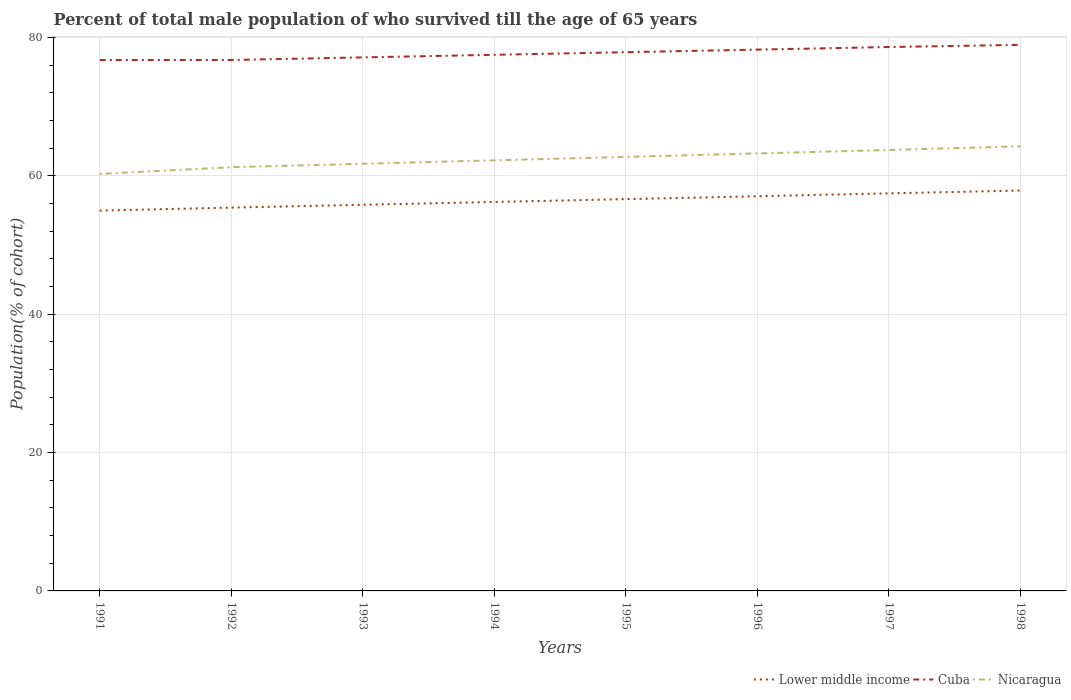Does the line corresponding to Nicaragua intersect with the line corresponding to Lower middle income?
Offer a terse response. No. Is the number of lines equal to the number of legend labels?
Your response must be concise. Yes. Across all years, what is the maximum percentage of total male population who survived till the age of 65 years in Nicaragua?
Ensure brevity in your answer.  60.29. What is the total percentage of total male population who survived till the age of 65 years in Cuba in the graph?
Offer a very short reply. -0. What is the difference between the highest and the second highest percentage of total male population who survived till the age of 65 years in Lower middle income?
Ensure brevity in your answer.  2.9. How many lines are there?
Give a very brief answer. 3. How many years are there in the graph?
Ensure brevity in your answer.  8. How are the legend labels stacked?
Ensure brevity in your answer.  Horizontal. What is the title of the graph?
Your response must be concise. Percent of total male population of who survived till the age of 65 years. What is the label or title of the Y-axis?
Provide a succinct answer. Population(% of cohort). What is the Population(% of cohort) of Lower middle income in 1991?
Provide a succinct answer. 54.98. What is the Population(% of cohort) in Cuba in 1991?
Make the answer very short. 76.75. What is the Population(% of cohort) of Nicaragua in 1991?
Provide a short and direct response. 60.29. What is the Population(% of cohort) of Lower middle income in 1992?
Ensure brevity in your answer.  55.41. What is the Population(% of cohort) in Cuba in 1992?
Keep it short and to the point. 76.76. What is the Population(% of cohort) of Nicaragua in 1992?
Your response must be concise. 61.26. What is the Population(% of cohort) in Lower middle income in 1993?
Your answer should be very brief. 55.82. What is the Population(% of cohort) in Cuba in 1993?
Your answer should be very brief. 77.13. What is the Population(% of cohort) in Nicaragua in 1993?
Offer a terse response. 61.75. What is the Population(% of cohort) in Lower middle income in 1994?
Offer a very short reply. 56.23. What is the Population(% of cohort) in Cuba in 1994?
Provide a short and direct response. 77.51. What is the Population(% of cohort) in Nicaragua in 1994?
Your answer should be very brief. 62.25. What is the Population(% of cohort) in Lower middle income in 1995?
Offer a very short reply. 56.64. What is the Population(% of cohort) in Cuba in 1995?
Keep it short and to the point. 77.88. What is the Population(% of cohort) of Nicaragua in 1995?
Ensure brevity in your answer.  62.75. What is the Population(% of cohort) in Lower middle income in 1996?
Provide a short and direct response. 57.06. What is the Population(% of cohort) in Cuba in 1996?
Your answer should be compact. 78.25. What is the Population(% of cohort) of Nicaragua in 1996?
Make the answer very short. 63.25. What is the Population(% of cohort) in Lower middle income in 1997?
Provide a succinct answer. 57.48. What is the Population(% of cohort) in Cuba in 1997?
Make the answer very short. 78.63. What is the Population(% of cohort) of Nicaragua in 1997?
Your answer should be compact. 63.74. What is the Population(% of cohort) in Lower middle income in 1998?
Your answer should be very brief. 57.88. What is the Population(% of cohort) in Cuba in 1998?
Keep it short and to the point. 78.94. What is the Population(% of cohort) of Nicaragua in 1998?
Your answer should be compact. 64.27. Across all years, what is the maximum Population(% of cohort) in Lower middle income?
Make the answer very short. 57.88. Across all years, what is the maximum Population(% of cohort) in Cuba?
Provide a short and direct response. 78.94. Across all years, what is the maximum Population(% of cohort) in Nicaragua?
Keep it short and to the point. 64.27. Across all years, what is the minimum Population(% of cohort) in Lower middle income?
Ensure brevity in your answer.  54.98. Across all years, what is the minimum Population(% of cohort) in Cuba?
Make the answer very short. 76.75. Across all years, what is the minimum Population(% of cohort) in Nicaragua?
Ensure brevity in your answer.  60.29. What is the total Population(% of cohort) of Lower middle income in the graph?
Your response must be concise. 451.5. What is the total Population(% of cohort) in Cuba in the graph?
Keep it short and to the point. 621.86. What is the total Population(% of cohort) of Nicaragua in the graph?
Your answer should be very brief. 499.56. What is the difference between the Population(% of cohort) of Lower middle income in 1991 and that in 1992?
Offer a terse response. -0.43. What is the difference between the Population(% of cohort) of Cuba in 1991 and that in 1992?
Offer a terse response. -0. What is the difference between the Population(% of cohort) in Nicaragua in 1991 and that in 1992?
Provide a succinct answer. -0.97. What is the difference between the Population(% of cohort) of Lower middle income in 1991 and that in 1993?
Keep it short and to the point. -0.84. What is the difference between the Population(% of cohort) of Cuba in 1991 and that in 1993?
Your answer should be compact. -0.38. What is the difference between the Population(% of cohort) of Nicaragua in 1991 and that in 1993?
Your answer should be compact. -1.47. What is the difference between the Population(% of cohort) of Lower middle income in 1991 and that in 1994?
Your response must be concise. -1.25. What is the difference between the Population(% of cohort) in Cuba in 1991 and that in 1994?
Your response must be concise. -0.75. What is the difference between the Population(% of cohort) of Nicaragua in 1991 and that in 1994?
Make the answer very short. -1.96. What is the difference between the Population(% of cohort) in Lower middle income in 1991 and that in 1995?
Make the answer very short. -1.66. What is the difference between the Population(% of cohort) of Cuba in 1991 and that in 1995?
Keep it short and to the point. -1.13. What is the difference between the Population(% of cohort) of Nicaragua in 1991 and that in 1995?
Offer a terse response. -2.46. What is the difference between the Population(% of cohort) in Lower middle income in 1991 and that in 1996?
Your answer should be compact. -2.07. What is the difference between the Population(% of cohort) in Cuba in 1991 and that in 1996?
Your response must be concise. -1.5. What is the difference between the Population(% of cohort) of Nicaragua in 1991 and that in 1996?
Ensure brevity in your answer.  -2.96. What is the difference between the Population(% of cohort) in Lower middle income in 1991 and that in 1997?
Your answer should be very brief. -2.49. What is the difference between the Population(% of cohort) in Cuba in 1991 and that in 1997?
Keep it short and to the point. -1.87. What is the difference between the Population(% of cohort) in Nicaragua in 1991 and that in 1997?
Ensure brevity in your answer.  -3.46. What is the difference between the Population(% of cohort) of Lower middle income in 1991 and that in 1998?
Offer a very short reply. -2.9. What is the difference between the Population(% of cohort) of Cuba in 1991 and that in 1998?
Your response must be concise. -2.19. What is the difference between the Population(% of cohort) in Nicaragua in 1991 and that in 1998?
Give a very brief answer. -3.99. What is the difference between the Population(% of cohort) of Lower middle income in 1992 and that in 1993?
Make the answer very short. -0.41. What is the difference between the Population(% of cohort) of Cuba in 1992 and that in 1993?
Provide a short and direct response. -0.37. What is the difference between the Population(% of cohort) in Nicaragua in 1992 and that in 1993?
Provide a short and direct response. -0.5. What is the difference between the Population(% of cohort) of Lower middle income in 1992 and that in 1994?
Give a very brief answer. -0.82. What is the difference between the Population(% of cohort) in Cuba in 1992 and that in 1994?
Provide a short and direct response. -0.75. What is the difference between the Population(% of cohort) in Nicaragua in 1992 and that in 1994?
Offer a terse response. -1. What is the difference between the Population(% of cohort) of Lower middle income in 1992 and that in 1995?
Your answer should be compact. -1.23. What is the difference between the Population(% of cohort) in Cuba in 1992 and that in 1995?
Your answer should be compact. -1.12. What is the difference between the Population(% of cohort) in Nicaragua in 1992 and that in 1995?
Your answer should be very brief. -1.49. What is the difference between the Population(% of cohort) in Lower middle income in 1992 and that in 1996?
Your answer should be compact. -1.64. What is the difference between the Population(% of cohort) in Cuba in 1992 and that in 1996?
Keep it short and to the point. -1.5. What is the difference between the Population(% of cohort) in Nicaragua in 1992 and that in 1996?
Give a very brief answer. -1.99. What is the difference between the Population(% of cohort) in Lower middle income in 1992 and that in 1997?
Give a very brief answer. -2.06. What is the difference between the Population(% of cohort) of Cuba in 1992 and that in 1997?
Keep it short and to the point. -1.87. What is the difference between the Population(% of cohort) of Nicaragua in 1992 and that in 1997?
Offer a terse response. -2.49. What is the difference between the Population(% of cohort) of Lower middle income in 1992 and that in 1998?
Your answer should be compact. -2.47. What is the difference between the Population(% of cohort) in Cuba in 1992 and that in 1998?
Your answer should be compact. -2.18. What is the difference between the Population(% of cohort) in Nicaragua in 1992 and that in 1998?
Offer a terse response. -3.02. What is the difference between the Population(% of cohort) in Lower middle income in 1993 and that in 1994?
Ensure brevity in your answer.  -0.41. What is the difference between the Population(% of cohort) in Cuba in 1993 and that in 1994?
Make the answer very short. -0.37. What is the difference between the Population(% of cohort) in Nicaragua in 1993 and that in 1994?
Ensure brevity in your answer.  -0.5. What is the difference between the Population(% of cohort) of Lower middle income in 1993 and that in 1995?
Offer a terse response. -0.82. What is the difference between the Population(% of cohort) in Cuba in 1993 and that in 1995?
Keep it short and to the point. -0.75. What is the difference between the Population(% of cohort) in Nicaragua in 1993 and that in 1995?
Offer a terse response. -1. What is the difference between the Population(% of cohort) in Lower middle income in 1993 and that in 1996?
Make the answer very short. -1.24. What is the difference between the Population(% of cohort) of Cuba in 1993 and that in 1996?
Provide a short and direct response. -1.12. What is the difference between the Population(% of cohort) in Nicaragua in 1993 and that in 1996?
Ensure brevity in your answer.  -1.49. What is the difference between the Population(% of cohort) of Lower middle income in 1993 and that in 1997?
Offer a very short reply. -1.65. What is the difference between the Population(% of cohort) of Cuba in 1993 and that in 1997?
Make the answer very short. -1.5. What is the difference between the Population(% of cohort) in Nicaragua in 1993 and that in 1997?
Keep it short and to the point. -1.99. What is the difference between the Population(% of cohort) of Lower middle income in 1993 and that in 1998?
Keep it short and to the point. -2.06. What is the difference between the Population(% of cohort) in Cuba in 1993 and that in 1998?
Offer a very short reply. -1.81. What is the difference between the Population(% of cohort) of Nicaragua in 1993 and that in 1998?
Offer a very short reply. -2.52. What is the difference between the Population(% of cohort) of Lower middle income in 1994 and that in 1995?
Your answer should be compact. -0.41. What is the difference between the Population(% of cohort) of Cuba in 1994 and that in 1995?
Offer a very short reply. -0.37. What is the difference between the Population(% of cohort) of Nicaragua in 1994 and that in 1995?
Provide a succinct answer. -0.5. What is the difference between the Population(% of cohort) in Lower middle income in 1994 and that in 1996?
Your answer should be compact. -0.83. What is the difference between the Population(% of cohort) of Cuba in 1994 and that in 1996?
Offer a very short reply. -0.75. What is the difference between the Population(% of cohort) of Nicaragua in 1994 and that in 1996?
Provide a succinct answer. -1. What is the difference between the Population(% of cohort) of Lower middle income in 1994 and that in 1997?
Offer a very short reply. -1.25. What is the difference between the Population(% of cohort) in Cuba in 1994 and that in 1997?
Provide a succinct answer. -1.12. What is the difference between the Population(% of cohort) of Nicaragua in 1994 and that in 1997?
Provide a short and direct response. -1.49. What is the difference between the Population(% of cohort) in Lower middle income in 1994 and that in 1998?
Provide a succinct answer. -1.65. What is the difference between the Population(% of cohort) in Cuba in 1994 and that in 1998?
Your answer should be compact. -1.44. What is the difference between the Population(% of cohort) of Nicaragua in 1994 and that in 1998?
Ensure brevity in your answer.  -2.02. What is the difference between the Population(% of cohort) of Lower middle income in 1995 and that in 1996?
Make the answer very short. -0.42. What is the difference between the Population(% of cohort) in Cuba in 1995 and that in 1996?
Ensure brevity in your answer.  -0.37. What is the difference between the Population(% of cohort) in Nicaragua in 1995 and that in 1996?
Ensure brevity in your answer.  -0.5. What is the difference between the Population(% of cohort) in Lower middle income in 1995 and that in 1997?
Make the answer very short. -0.84. What is the difference between the Population(% of cohort) in Cuba in 1995 and that in 1997?
Your answer should be very brief. -0.75. What is the difference between the Population(% of cohort) in Nicaragua in 1995 and that in 1997?
Offer a terse response. -1. What is the difference between the Population(% of cohort) of Lower middle income in 1995 and that in 1998?
Your answer should be very brief. -1.24. What is the difference between the Population(% of cohort) in Cuba in 1995 and that in 1998?
Make the answer very short. -1.06. What is the difference between the Population(% of cohort) of Nicaragua in 1995 and that in 1998?
Provide a short and direct response. -1.52. What is the difference between the Population(% of cohort) of Lower middle income in 1996 and that in 1997?
Your answer should be compact. -0.42. What is the difference between the Population(% of cohort) of Cuba in 1996 and that in 1997?
Ensure brevity in your answer.  -0.37. What is the difference between the Population(% of cohort) of Nicaragua in 1996 and that in 1997?
Give a very brief answer. -0.5. What is the difference between the Population(% of cohort) of Lower middle income in 1996 and that in 1998?
Provide a short and direct response. -0.82. What is the difference between the Population(% of cohort) in Cuba in 1996 and that in 1998?
Make the answer very short. -0.69. What is the difference between the Population(% of cohort) of Nicaragua in 1996 and that in 1998?
Make the answer very short. -1.03. What is the difference between the Population(% of cohort) of Lower middle income in 1997 and that in 1998?
Your answer should be very brief. -0.4. What is the difference between the Population(% of cohort) in Cuba in 1997 and that in 1998?
Make the answer very short. -0.31. What is the difference between the Population(% of cohort) in Nicaragua in 1997 and that in 1998?
Your response must be concise. -0.53. What is the difference between the Population(% of cohort) in Lower middle income in 1991 and the Population(% of cohort) in Cuba in 1992?
Offer a very short reply. -21.77. What is the difference between the Population(% of cohort) in Lower middle income in 1991 and the Population(% of cohort) in Nicaragua in 1992?
Provide a short and direct response. -6.27. What is the difference between the Population(% of cohort) in Lower middle income in 1991 and the Population(% of cohort) in Cuba in 1993?
Your response must be concise. -22.15. What is the difference between the Population(% of cohort) in Lower middle income in 1991 and the Population(% of cohort) in Nicaragua in 1993?
Your answer should be compact. -6.77. What is the difference between the Population(% of cohort) of Cuba in 1991 and the Population(% of cohort) of Nicaragua in 1993?
Your response must be concise. 15. What is the difference between the Population(% of cohort) in Lower middle income in 1991 and the Population(% of cohort) in Cuba in 1994?
Give a very brief answer. -22.52. What is the difference between the Population(% of cohort) in Lower middle income in 1991 and the Population(% of cohort) in Nicaragua in 1994?
Your response must be concise. -7.27. What is the difference between the Population(% of cohort) in Cuba in 1991 and the Population(% of cohort) in Nicaragua in 1994?
Provide a succinct answer. 14.5. What is the difference between the Population(% of cohort) of Lower middle income in 1991 and the Population(% of cohort) of Cuba in 1995?
Keep it short and to the point. -22.9. What is the difference between the Population(% of cohort) in Lower middle income in 1991 and the Population(% of cohort) in Nicaragua in 1995?
Provide a succinct answer. -7.77. What is the difference between the Population(% of cohort) of Cuba in 1991 and the Population(% of cohort) of Nicaragua in 1995?
Your answer should be very brief. 14.01. What is the difference between the Population(% of cohort) of Lower middle income in 1991 and the Population(% of cohort) of Cuba in 1996?
Provide a short and direct response. -23.27. What is the difference between the Population(% of cohort) of Lower middle income in 1991 and the Population(% of cohort) of Nicaragua in 1996?
Make the answer very short. -8.26. What is the difference between the Population(% of cohort) in Cuba in 1991 and the Population(% of cohort) in Nicaragua in 1996?
Make the answer very short. 13.51. What is the difference between the Population(% of cohort) of Lower middle income in 1991 and the Population(% of cohort) of Cuba in 1997?
Keep it short and to the point. -23.65. What is the difference between the Population(% of cohort) of Lower middle income in 1991 and the Population(% of cohort) of Nicaragua in 1997?
Offer a terse response. -8.76. What is the difference between the Population(% of cohort) of Cuba in 1991 and the Population(% of cohort) of Nicaragua in 1997?
Your answer should be very brief. 13.01. What is the difference between the Population(% of cohort) of Lower middle income in 1991 and the Population(% of cohort) of Cuba in 1998?
Provide a short and direct response. -23.96. What is the difference between the Population(% of cohort) of Lower middle income in 1991 and the Population(% of cohort) of Nicaragua in 1998?
Keep it short and to the point. -9.29. What is the difference between the Population(% of cohort) in Cuba in 1991 and the Population(% of cohort) in Nicaragua in 1998?
Your response must be concise. 12.48. What is the difference between the Population(% of cohort) in Lower middle income in 1992 and the Population(% of cohort) in Cuba in 1993?
Provide a short and direct response. -21.72. What is the difference between the Population(% of cohort) in Lower middle income in 1992 and the Population(% of cohort) in Nicaragua in 1993?
Offer a terse response. -6.34. What is the difference between the Population(% of cohort) in Cuba in 1992 and the Population(% of cohort) in Nicaragua in 1993?
Give a very brief answer. 15.01. What is the difference between the Population(% of cohort) in Lower middle income in 1992 and the Population(% of cohort) in Cuba in 1994?
Keep it short and to the point. -22.09. What is the difference between the Population(% of cohort) of Lower middle income in 1992 and the Population(% of cohort) of Nicaragua in 1994?
Offer a very short reply. -6.84. What is the difference between the Population(% of cohort) in Cuba in 1992 and the Population(% of cohort) in Nicaragua in 1994?
Offer a very short reply. 14.51. What is the difference between the Population(% of cohort) in Lower middle income in 1992 and the Population(% of cohort) in Cuba in 1995?
Offer a very short reply. -22.47. What is the difference between the Population(% of cohort) of Lower middle income in 1992 and the Population(% of cohort) of Nicaragua in 1995?
Provide a succinct answer. -7.34. What is the difference between the Population(% of cohort) in Cuba in 1992 and the Population(% of cohort) in Nicaragua in 1995?
Provide a short and direct response. 14.01. What is the difference between the Population(% of cohort) in Lower middle income in 1992 and the Population(% of cohort) in Cuba in 1996?
Provide a succinct answer. -22.84. What is the difference between the Population(% of cohort) in Lower middle income in 1992 and the Population(% of cohort) in Nicaragua in 1996?
Make the answer very short. -7.83. What is the difference between the Population(% of cohort) in Cuba in 1992 and the Population(% of cohort) in Nicaragua in 1996?
Your answer should be very brief. 13.51. What is the difference between the Population(% of cohort) of Lower middle income in 1992 and the Population(% of cohort) of Cuba in 1997?
Keep it short and to the point. -23.22. What is the difference between the Population(% of cohort) of Lower middle income in 1992 and the Population(% of cohort) of Nicaragua in 1997?
Your answer should be compact. -8.33. What is the difference between the Population(% of cohort) of Cuba in 1992 and the Population(% of cohort) of Nicaragua in 1997?
Your response must be concise. 13.01. What is the difference between the Population(% of cohort) of Lower middle income in 1992 and the Population(% of cohort) of Cuba in 1998?
Provide a short and direct response. -23.53. What is the difference between the Population(% of cohort) in Lower middle income in 1992 and the Population(% of cohort) in Nicaragua in 1998?
Your response must be concise. -8.86. What is the difference between the Population(% of cohort) in Cuba in 1992 and the Population(% of cohort) in Nicaragua in 1998?
Provide a short and direct response. 12.49. What is the difference between the Population(% of cohort) in Lower middle income in 1993 and the Population(% of cohort) in Cuba in 1994?
Give a very brief answer. -21.68. What is the difference between the Population(% of cohort) of Lower middle income in 1993 and the Population(% of cohort) of Nicaragua in 1994?
Provide a short and direct response. -6.43. What is the difference between the Population(% of cohort) in Cuba in 1993 and the Population(% of cohort) in Nicaragua in 1994?
Your answer should be compact. 14.88. What is the difference between the Population(% of cohort) of Lower middle income in 1993 and the Population(% of cohort) of Cuba in 1995?
Your answer should be very brief. -22.06. What is the difference between the Population(% of cohort) of Lower middle income in 1993 and the Population(% of cohort) of Nicaragua in 1995?
Make the answer very short. -6.93. What is the difference between the Population(% of cohort) in Cuba in 1993 and the Population(% of cohort) in Nicaragua in 1995?
Your answer should be compact. 14.38. What is the difference between the Population(% of cohort) in Lower middle income in 1993 and the Population(% of cohort) in Cuba in 1996?
Ensure brevity in your answer.  -22.43. What is the difference between the Population(% of cohort) in Lower middle income in 1993 and the Population(% of cohort) in Nicaragua in 1996?
Offer a terse response. -7.42. What is the difference between the Population(% of cohort) of Cuba in 1993 and the Population(% of cohort) of Nicaragua in 1996?
Your answer should be compact. 13.89. What is the difference between the Population(% of cohort) in Lower middle income in 1993 and the Population(% of cohort) in Cuba in 1997?
Provide a succinct answer. -22.81. What is the difference between the Population(% of cohort) of Lower middle income in 1993 and the Population(% of cohort) of Nicaragua in 1997?
Provide a succinct answer. -7.92. What is the difference between the Population(% of cohort) in Cuba in 1993 and the Population(% of cohort) in Nicaragua in 1997?
Provide a succinct answer. 13.39. What is the difference between the Population(% of cohort) of Lower middle income in 1993 and the Population(% of cohort) of Cuba in 1998?
Offer a terse response. -23.12. What is the difference between the Population(% of cohort) in Lower middle income in 1993 and the Population(% of cohort) in Nicaragua in 1998?
Give a very brief answer. -8.45. What is the difference between the Population(% of cohort) of Cuba in 1993 and the Population(% of cohort) of Nicaragua in 1998?
Your response must be concise. 12.86. What is the difference between the Population(% of cohort) in Lower middle income in 1994 and the Population(% of cohort) in Cuba in 1995?
Ensure brevity in your answer.  -21.65. What is the difference between the Population(% of cohort) in Lower middle income in 1994 and the Population(% of cohort) in Nicaragua in 1995?
Ensure brevity in your answer.  -6.52. What is the difference between the Population(% of cohort) of Cuba in 1994 and the Population(% of cohort) of Nicaragua in 1995?
Your answer should be compact. 14.76. What is the difference between the Population(% of cohort) in Lower middle income in 1994 and the Population(% of cohort) in Cuba in 1996?
Provide a succinct answer. -22.02. What is the difference between the Population(% of cohort) in Lower middle income in 1994 and the Population(% of cohort) in Nicaragua in 1996?
Your answer should be very brief. -7.02. What is the difference between the Population(% of cohort) of Cuba in 1994 and the Population(% of cohort) of Nicaragua in 1996?
Keep it short and to the point. 14.26. What is the difference between the Population(% of cohort) in Lower middle income in 1994 and the Population(% of cohort) in Cuba in 1997?
Provide a short and direct response. -22.4. What is the difference between the Population(% of cohort) in Lower middle income in 1994 and the Population(% of cohort) in Nicaragua in 1997?
Offer a very short reply. -7.51. What is the difference between the Population(% of cohort) of Cuba in 1994 and the Population(% of cohort) of Nicaragua in 1997?
Provide a succinct answer. 13.76. What is the difference between the Population(% of cohort) in Lower middle income in 1994 and the Population(% of cohort) in Cuba in 1998?
Give a very brief answer. -22.71. What is the difference between the Population(% of cohort) of Lower middle income in 1994 and the Population(% of cohort) of Nicaragua in 1998?
Ensure brevity in your answer.  -8.04. What is the difference between the Population(% of cohort) of Cuba in 1994 and the Population(% of cohort) of Nicaragua in 1998?
Offer a very short reply. 13.23. What is the difference between the Population(% of cohort) of Lower middle income in 1995 and the Population(% of cohort) of Cuba in 1996?
Give a very brief answer. -21.61. What is the difference between the Population(% of cohort) of Lower middle income in 1995 and the Population(% of cohort) of Nicaragua in 1996?
Your response must be concise. -6.61. What is the difference between the Population(% of cohort) in Cuba in 1995 and the Population(% of cohort) in Nicaragua in 1996?
Give a very brief answer. 14.63. What is the difference between the Population(% of cohort) of Lower middle income in 1995 and the Population(% of cohort) of Cuba in 1997?
Keep it short and to the point. -21.99. What is the difference between the Population(% of cohort) of Lower middle income in 1995 and the Population(% of cohort) of Nicaragua in 1997?
Offer a terse response. -7.1. What is the difference between the Population(% of cohort) in Cuba in 1995 and the Population(% of cohort) in Nicaragua in 1997?
Give a very brief answer. 14.14. What is the difference between the Population(% of cohort) of Lower middle income in 1995 and the Population(% of cohort) of Cuba in 1998?
Make the answer very short. -22.3. What is the difference between the Population(% of cohort) of Lower middle income in 1995 and the Population(% of cohort) of Nicaragua in 1998?
Give a very brief answer. -7.63. What is the difference between the Population(% of cohort) in Cuba in 1995 and the Population(% of cohort) in Nicaragua in 1998?
Offer a terse response. 13.61. What is the difference between the Population(% of cohort) of Lower middle income in 1996 and the Population(% of cohort) of Cuba in 1997?
Ensure brevity in your answer.  -21.57. What is the difference between the Population(% of cohort) in Lower middle income in 1996 and the Population(% of cohort) in Nicaragua in 1997?
Ensure brevity in your answer.  -6.69. What is the difference between the Population(% of cohort) in Cuba in 1996 and the Population(% of cohort) in Nicaragua in 1997?
Ensure brevity in your answer.  14.51. What is the difference between the Population(% of cohort) in Lower middle income in 1996 and the Population(% of cohort) in Cuba in 1998?
Provide a succinct answer. -21.88. What is the difference between the Population(% of cohort) of Lower middle income in 1996 and the Population(% of cohort) of Nicaragua in 1998?
Offer a very short reply. -7.21. What is the difference between the Population(% of cohort) in Cuba in 1996 and the Population(% of cohort) in Nicaragua in 1998?
Offer a terse response. 13.98. What is the difference between the Population(% of cohort) in Lower middle income in 1997 and the Population(% of cohort) in Cuba in 1998?
Provide a succinct answer. -21.47. What is the difference between the Population(% of cohort) in Lower middle income in 1997 and the Population(% of cohort) in Nicaragua in 1998?
Give a very brief answer. -6.8. What is the difference between the Population(% of cohort) of Cuba in 1997 and the Population(% of cohort) of Nicaragua in 1998?
Your response must be concise. 14.36. What is the average Population(% of cohort) in Lower middle income per year?
Ensure brevity in your answer.  56.44. What is the average Population(% of cohort) of Cuba per year?
Make the answer very short. 77.73. What is the average Population(% of cohort) in Nicaragua per year?
Your answer should be compact. 62.44. In the year 1991, what is the difference between the Population(% of cohort) of Lower middle income and Population(% of cohort) of Cuba?
Your response must be concise. -21.77. In the year 1991, what is the difference between the Population(% of cohort) in Lower middle income and Population(% of cohort) in Nicaragua?
Provide a short and direct response. -5.3. In the year 1991, what is the difference between the Population(% of cohort) of Cuba and Population(% of cohort) of Nicaragua?
Keep it short and to the point. 16.47. In the year 1992, what is the difference between the Population(% of cohort) in Lower middle income and Population(% of cohort) in Cuba?
Your response must be concise. -21.34. In the year 1992, what is the difference between the Population(% of cohort) of Lower middle income and Population(% of cohort) of Nicaragua?
Make the answer very short. -5.84. In the year 1992, what is the difference between the Population(% of cohort) of Cuba and Population(% of cohort) of Nicaragua?
Offer a terse response. 15.5. In the year 1993, what is the difference between the Population(% of cohort) of Lower middle income and Population(% of cohort) of Cuba?
Provide a short and direct response. -21.31. In the year 1993, what is the difference between the Population(% of cohort) in Lower middle income and Population(% of cohort) in Nicaragua?
Offer a very short reply. -5.93. In the year 1993, what is the difference between the Population(% of cohort) in Cuba and Population(% of cohort) in Nicaragua?
Offer a terse response. 15.38. In the year 1994, what is the difference between the Population(% of cohort) in Lower middle income and Population(% of cohort) in Cuba?
Provide a short and direct response. -21.28. In the year 1994, what is the difference between the Population(% of cohort) of Lower middle income and Population(% of cohort) of Nicaragua?
Your answer should be very brief. -6.02. In the year 1994, what is the difference between the Population(% of cohort) in Cuba and Population(% of cohort) in Nicaragua?
Give a very brief answer. 15.26. In the year 1995, what is the difference between the Population(% of cohort) of Lower middle income and Population(% of cohort) of Cuba?
Make the answer very short. -21.24. In the year 1995, what is the difference between the Population(% of cohort) of Lower middle income and Population(% of cohort) of Nicaragua?
Offer a very short reply. -6.11. In the year 1995, what is the difference between the Population(% of cohort) of Cuba and Population(% of cohort) of Nicaragua?
Make the answer very short. 15.13. In the year 1996, what is the difference between the Population(% of cohort) in Lower middle income and Population(% of cohort) in Cuba?
Provide a short and direct response. -21.2. In the year 1996, what is the difference between the Population(% of cohort) in Lower middle income and Population(% of cohort) in Nicaragua?
Keep it short and to the point. -6.19. In the year 1996, what is the difference between the Population(% of cohort) of Cuba and Population(% of cohort) of Nicaragua?
Offer a terse response. 15.01. In the year 1997, what is the difference between the Population(% of cohort) of Lower middle income and Population(% of cohort) of Cuba?
Your response must be concise. -21.15. In the year 1997, what is the difference between the Population(% of cohort) of Lower middle income and Population(% of cohort) of Nicaragua?
Your response must be concise. -6.27. In the year 1997, what is the difference between the Population(% of cohort) in Cuba and Population(% of cohort) in Nicaragua?
Offer a terse response. 14.88. In the year 1998, what is the difference between the Population(% of cohort) in Lower middle income and Population(% of cohort) in Cuba?
Keep it short and to the point. -21.06. In the year 1998, what is the difference between the Population(% of cohort) of Lower middle income and Population(% of cohort) of Nicaragua?
Provide a short and direct response. -6.39. In the year 1998, what is the difference between the Population(% of cohort) of Cuba and Population(% of cohort) of Nicaragua?
Keep it short and to the point. 14.67. What is the ratio of the Population(% of cohort) in Lower middle income in 1991 to that in 1992?
Offer a very short reply. 0.99. What is the ratio of the Population(% of cohort) in Cuba in 1991 to that in 1992?
Offer a terse response. 1. What is the ratio of the Population(% of cohort) in Nicaragua in 1991 to that in 1992?
Provide a succinct answer. 0.98. What is the ratio of the Population(% of cohort) of Nicaragua in 1991 to that in 1993?
Provide a succinct answer. 0.98. What is the ratio of the Population(% of cohort) of Lower middle income in 1991 to that in 1994?
Keep it short and to the point. 0.98. What is the ratio of the Population(% of cohort) in Cuba in 1991 to that in 1994?
Your answer should be very brief. 0.99. What is the ratio of the Population(% of cohort) in Nicaragua in 1991 to that in 1994?
Keep it short and to the point. 0.97. What is the ratio of the Population(% of cohort) in Lower middle income in 1991 to that in 1995?
Your answer should be compact. 0.97. What is the ratio of the Population(% of cohort) in Cuba in 1991 to that in 1995?
Your response must be concise. 0.99. What is the ratio of the Population(% of cohort) in Nicaragua in 1991 to that in 1995?
Your answer should be compact. 0.96. What is the ratio of the Population(% of cohort) of Lower middle income in 1991 to that in 1996?
Keep it short and to the point. 0.96. What is the ratio of the Population(% of cohort) in Cuba in 1991 to that in 1996?
Offer a very short reply. 0.98. What is the ratio of the Population(% of cohort) in Nicaragua in 1991 to that in 1996?
Your answer should be very brief. 0.95. What is the ratio of the Population(% of cohort) of Lower middle income in 1991 to that in 1997?
Provide a succinct answer. 0.96. What is the ratio of the Population(% of cohort) of Cuba in 1991 to that in 1997?
Provide a succinct answer. 0.98. What is the ratio of the Population(% of cohort) of Nicaragua in 1991 to that in 1997?
Offer a terse response. 0.95. What is the ratio of the Population(% of cohort) in Cuba in 1991 to that in 1998?
Provide a succinct answer. 0.97. What is the ratio of the Population(% of cohort) in Nicaragua in 1991 to that in 1998?
Offer a very short reply. 0.94. What is the ratio of the Population(% of cohort) of Lower middle income in 1992 to that in 1993?
Your answer should be compact. 0.99. What is the ratio of the Population(% of cohort) in Lower middle income in 1992 to that in 1994?
Provide a short and direct response. 0.99. What is the ratio of the Population(% of cohort) of Cuba in 1992 to that in 1994?
Your answer should be very brief. 0.99. What is the ratio of the Population(% of cohort) of Nicaragua in 1992 to that in 1994?
Your answer should be compact. 0.98. What is the ratio of the Population(% of cohort) in Lower middle income in 1992 to that in 1995?
Your response must be concise. 0.98. What is the ratio of the Population(% of cohort) in Cuba in 1992 to that in 1995?
Ensure brevity in your answer.  0.99. What is the ratio of the Population(% of cohort) of Nicaragua in 1992 to that in 1995?
Give a very brief answer. 0.98. What is the ratio of the Population(% of cohort) of Lower middle income in 1992 to that in 1996?
Make the answer very short. 0.97. What is the ratio of the Population(% of cohort) in Cuba in 1992 to that in 1996?
Provide a short and direct response. 0.98. What is the ratio of the Population(% of cohort) of Nicaragua in 1992 to that in 1996?
Your answer should be compact. 0.97. What is the ratio of the Population(% of cohort) of Lower middle income in 1992 to that in 1997?
Give a very brief answer. 0.96. What is the ratio of the Population(% of cohort) of Cuba in 1992 to that in 1997?
Your answer should be very brief. 0.98. What is the ratio of the Population(% of cohort) of Nicaragua in 1992 to that in 1997?
Offer a very short reply. 0.96. What is the ratio of the Population(% of cohort) in Lower middle income in 1992 to that in 1998?
Offer a terse response. 0.96. What is the ratio of the Population(% of cohort) in Cuba in 1992 to that in 1998?
Offer a very short reply. 0.97. What is the ratio of the Population(% of cohort) in Nicaragua in 1992 to that in 1998?
Provide a succinct answer. 0.95. What is the ratio of the Population(% of cohort) of Lower middle income in 1993 to that in 1994?
Your response must be concise. 0.99. What is the ratio of the Population(% of cohort) of Nicaragua in 1993 to that in 1994?
Make the answer very short. 0.99. What is the ratio of the Population(% of cohort) in Lower middle income in 1993 to that in 1995?
Make the answer very short. 0.99. What is the ratio of the Population(% of cohort) in Nicaragua in 1993 to that in 1995?
Offer a terse response. 0.98. What is the ratio of the Population(% of cohort) in Lower middle income in 1993 to that in 1996?
Offer a very short reply. 0.98. What is the ratio of the Population(% of cohort) in Cuba in 1993 to that in 1996?
Ensure brevity in your answer.  0.99. What is the ratio of the Population(% of cohort) of Nicaragua in 1993 to that in 1996?
Offer a terse response. 0.98. What is the ratio of the Population(% of cohort) in Lower middle income in 1993 to that in 1997?
Ensure brevity in your answer.  0.97. What is the ratio of the Population(% of cohort) of Cuba in 1993 to that in 1997?
Your answer should be compact. 0.98. What is the ratio of the Population(% of cohort) in Nicaragua in 1993 to that in 1997?
Offer a very short reply. 0.97. What is the ratio of the Population(% of cohort) of Lower middle income in 1993 to that in 1998?
Make the answer very short. 0.96. What is the ratio of the Population(% of cohort) in Cuba in 1993 to that in 1998?
Keep it short and to the point. 0.98. What is the ratio of the Population(% of cohort) in Nicaragua in 1993 to that in 1998?
Keep it short and to the point. 0.96. What is the ratio of the Population(% of cohort) in Cuba in 1994 to that in 1995?
Offer a terse response. 1. What is the ratio of the Population(% of cohort) in Nicaragua in 1994 to that in 1995?
Keep it short and to the point. 0.99. What is the ratio of the Population(% of cohort) in Lower middle income in 1994 to that in 1996?
Provide a succinct answer. 0.99. What is the ratio of the Population(% of cohort) in Cuba in 1994 to that in 1996?
Provide a short and direct response. 0.99. What is the ratio of the Population(% of cohort) in Nicaragua in 1994 to that in 1996?
Your answer should be compact. 0.98. What is the ratio of the Population(% of cohort) in Lower middle income in 1994 to that in 1997?
Provide a short and direct response. 0.98. What is the ratio of the Population(% of cohort) of Cuba in 1994 to that in 1997?
Provide a succinct answer. 0.99. What is the ratio of the Population(% of cohort) in Nicaragua in 1994 to that in 1997?
Provide a short and direct response. 0.98. What is the ratio of the Population(% of cohort) in Lower middle income in 1994 to that in 1998?
Offer a terse response. 0.97. What is the ratio of the Population(% of cohort) in Cuba in 1994 to that in 1998?
Your answer should be very brief. 0.98. What is the ratio of the Population(% of cohort) in Nicaragua in 1994 to that in 1998?
Ensure brevity in your answer.  0.97. What is the ratio of the Population(% of cohort) of Nicaragua in 1995 to that in 1996?
Ensure brevity in your answer.  0.99. What is the ratio of the Population(% of cohort) in Lower middle income in 1995 to that in 1997?
Provide a succinct answer. 0.99. What is the ratio of the Population(% of cohort) of Cuba in 1995 to that in 1997?
Ensure brevity in your answer.  0.99. What is the ratio of the Population(% of cohort) of Nicaragua in 1995 to that in 1997?
Your answer should be compact. 0.98. What is the ratio of the Population(% of cohort) in Lower middle income in 1995 to that in 1998?
Your answer should be very brief. 0.98. What is the ratio of the Population(% of cohort) in Cuba in 1995 to that in 1998?
Keep it short and to the point. 0.99. What is the ratio of the Population(% of cohort) in Nicaragua in 1995 to that in 1998?
Keep it short and to the point. 0.98. What is the ratio of the Population(% of cohort) of Lower middle income in 1996 to that in 1997?
Offer a terse response. 0.99. What is the ratio of the Population(% of cohort) in Nicaragua in 1996 to that in 1997?
Ensure brevity in your answer.  0.99. What is the ratio of the Population(% of cohort) of Lower middle income in 1996 to that in 1998?
Ensure brevity in your answer.  0.99. What is the ratio of the Population(% of cohort) in Nicaragua in 1996 to that in 1998?
Provide a succinct answer. 0.98. What is the difference between the highest and the second highest Population(% of cohort) in Lower middle income?
Ensure brevity in your answer.  0.4. What is the difference between the highest and the second highest Population(% of cohort) of Cuba?
Your answer should be compact. 0.31. What is the difference between the highest and the second highest Population(% of cohort) of Nicaragua?
Ensure brevity in your answer.  0.53. What is the difference between the highest and the lowest Population(% of cohort) of Lower middle income?
Provide a short and direct response. 2.9. What is the difference between the highest and the lowest Population(% of cohort) in Cuba?
Keep it short and to the point. 2.19. What is the difference between the highest and the lowest Population(% of cohort) in Nicaragua?
Offer a very short reply. 3.99. 